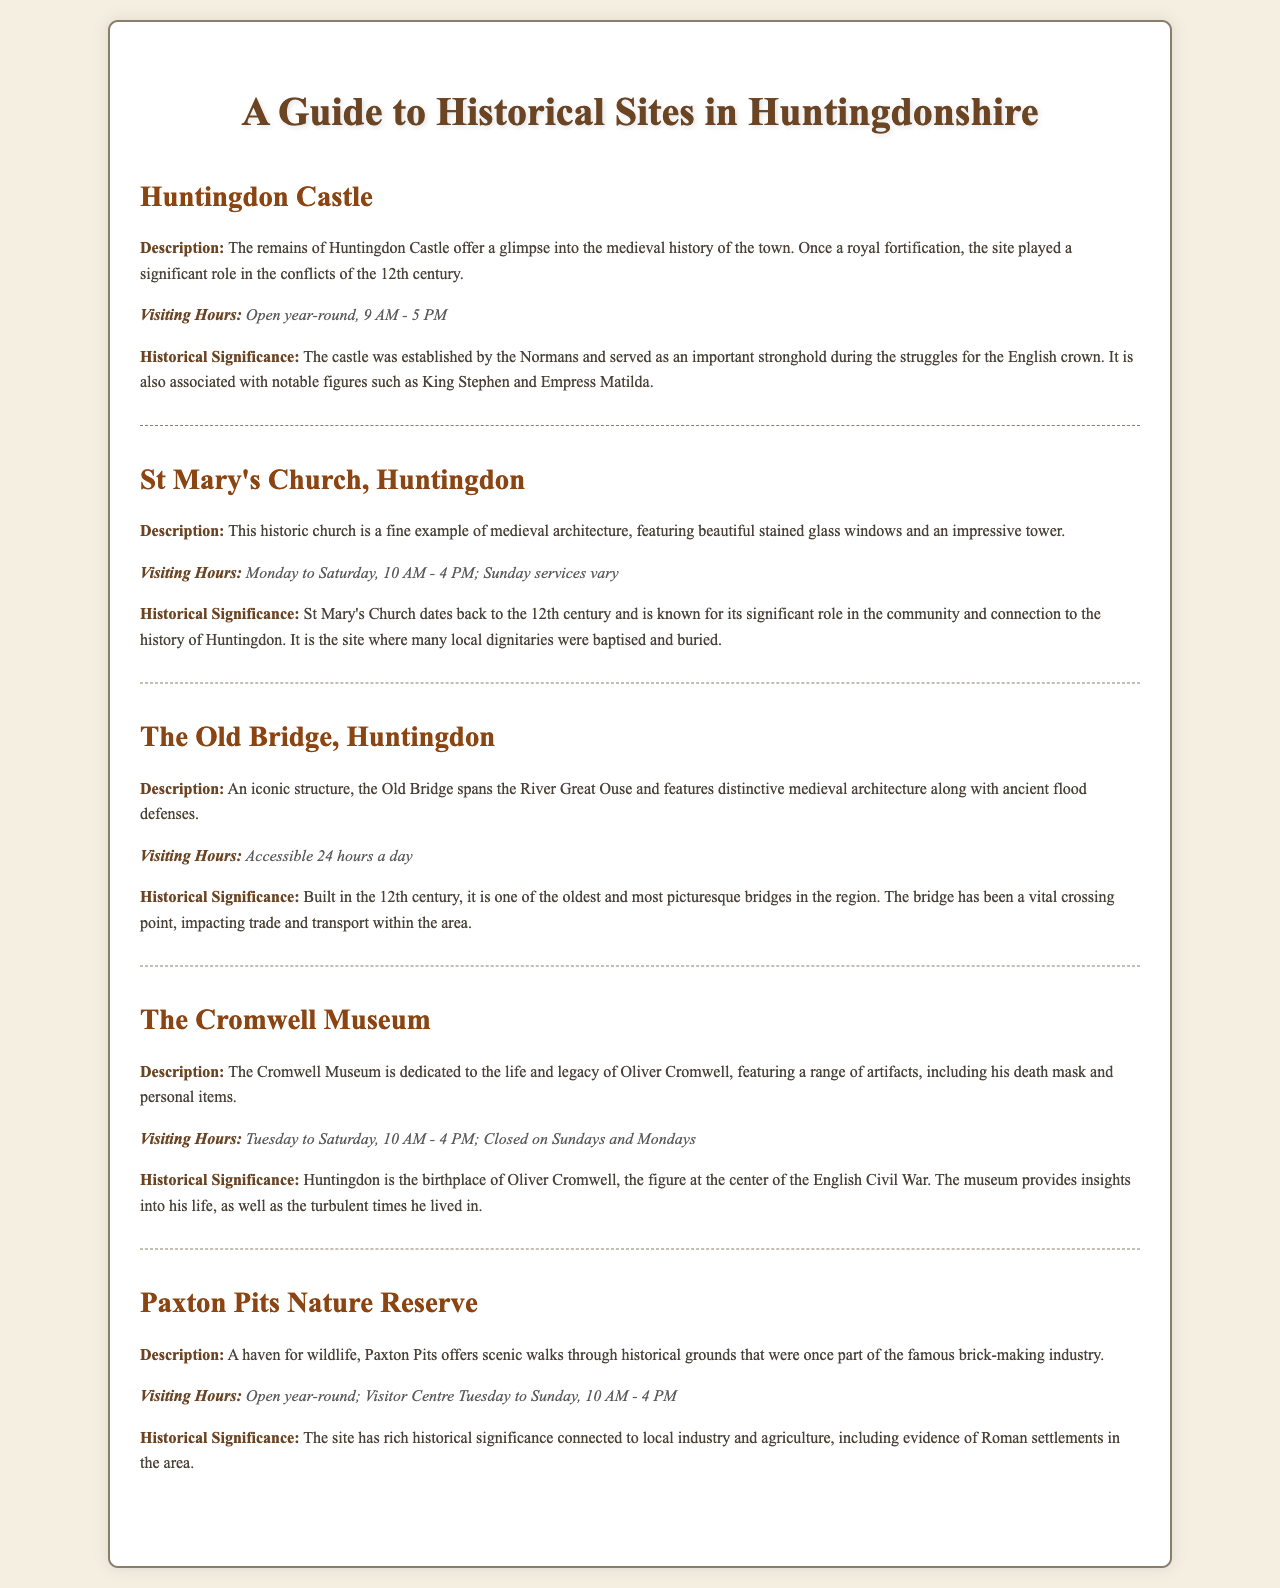What is the description of Huntingdon Castle? The description provides details about the remains of Huntingdon Castle and its significance as a medieval fortification involved in 12th-century conflicts.
Answer: The remains of Huntingdon Castle offer a glimpse into the medieval history of the town What are the visiting hours for St Mary's Church? The visiting hours for St Mary's Church detail the days and times it is open to the public.
Answer: Monday to Saturday, 10 AM - 4 PM; Sunday services vary What architectural style is The Old Bridge known for? The document specifies that The Old Bridge features distinctive medieval architecture.
Answer: Medieval architecture What significant figure is associated with The Cromwell Museum? The museum is dedicated to a key historical figure from Huntingdon's history related to the English Civil War.
Answer: Oliver Cromwell What is the historical significance of Paxton Pits Nature Reserve? The explanation covers the historical aspects linked to local industry, agriculture, and evidence of Roman settlements.
Answer: Rich historical significance connected to local industry and agriculture, including evidence of Roman settlements 